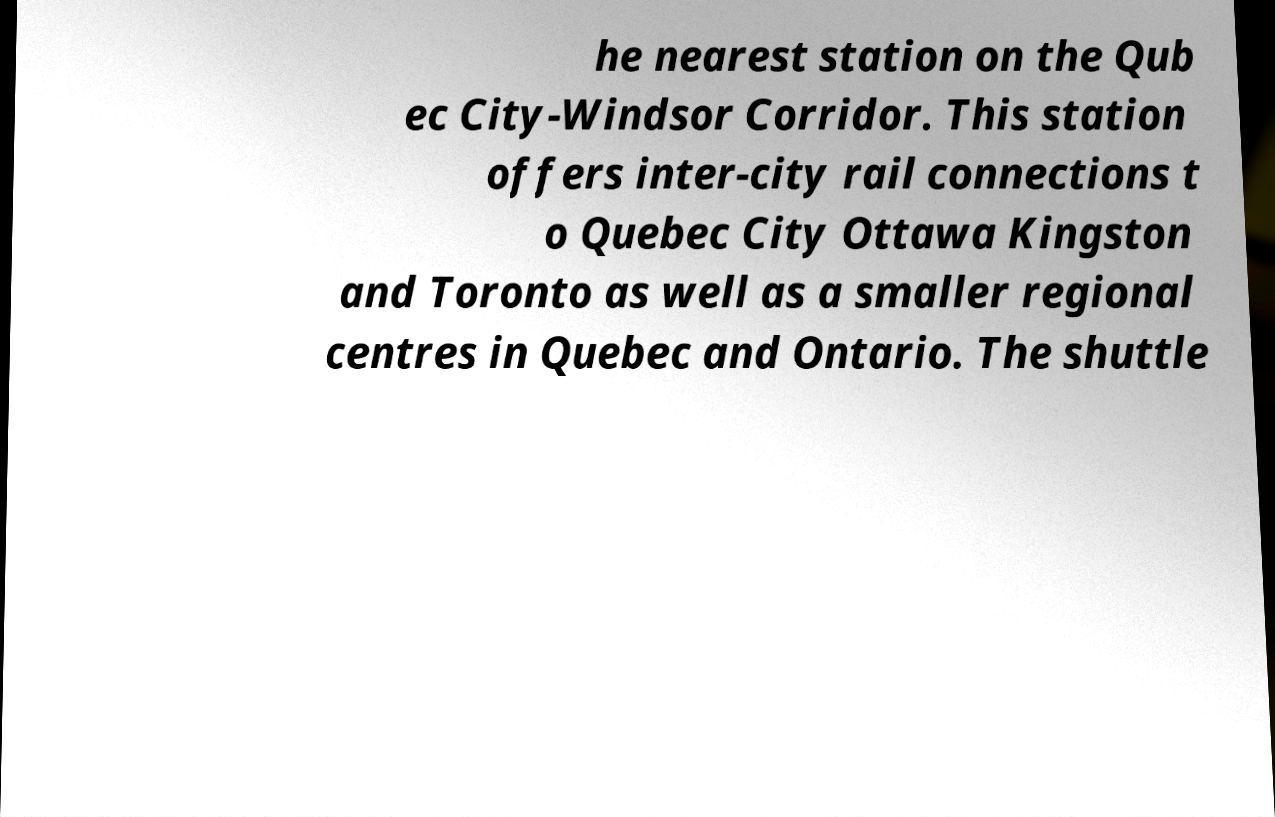There's text embedded in this image that I need extracted. Can you transcribe it verbatim? he nearest station on the Qub ec City-Windsor Corridor. This station offers inter-city rail connections t o Quebec City Ottawa Kingston and Toronto as well as a smaller regional centres in Quebec and Ontario. The shuttle 